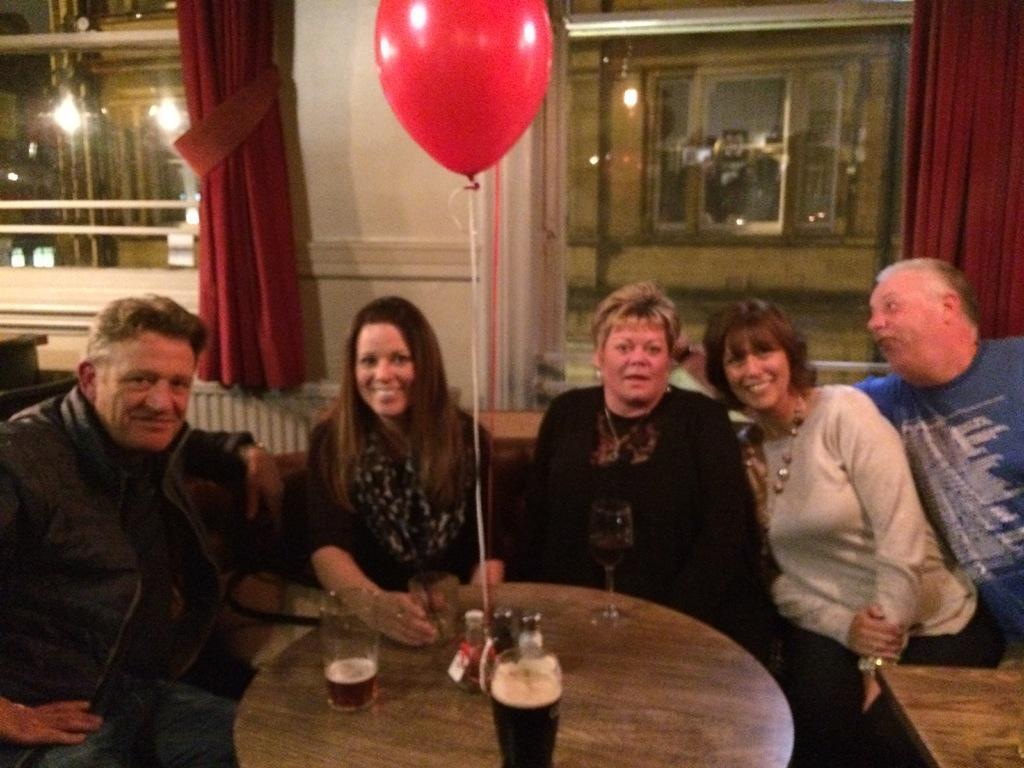In one or two sentences, can you explain what this image depicts? This picture shows a group of people seated on the chairs and we see glasses and a balloon hanging on the table and we see curtains to the windows 